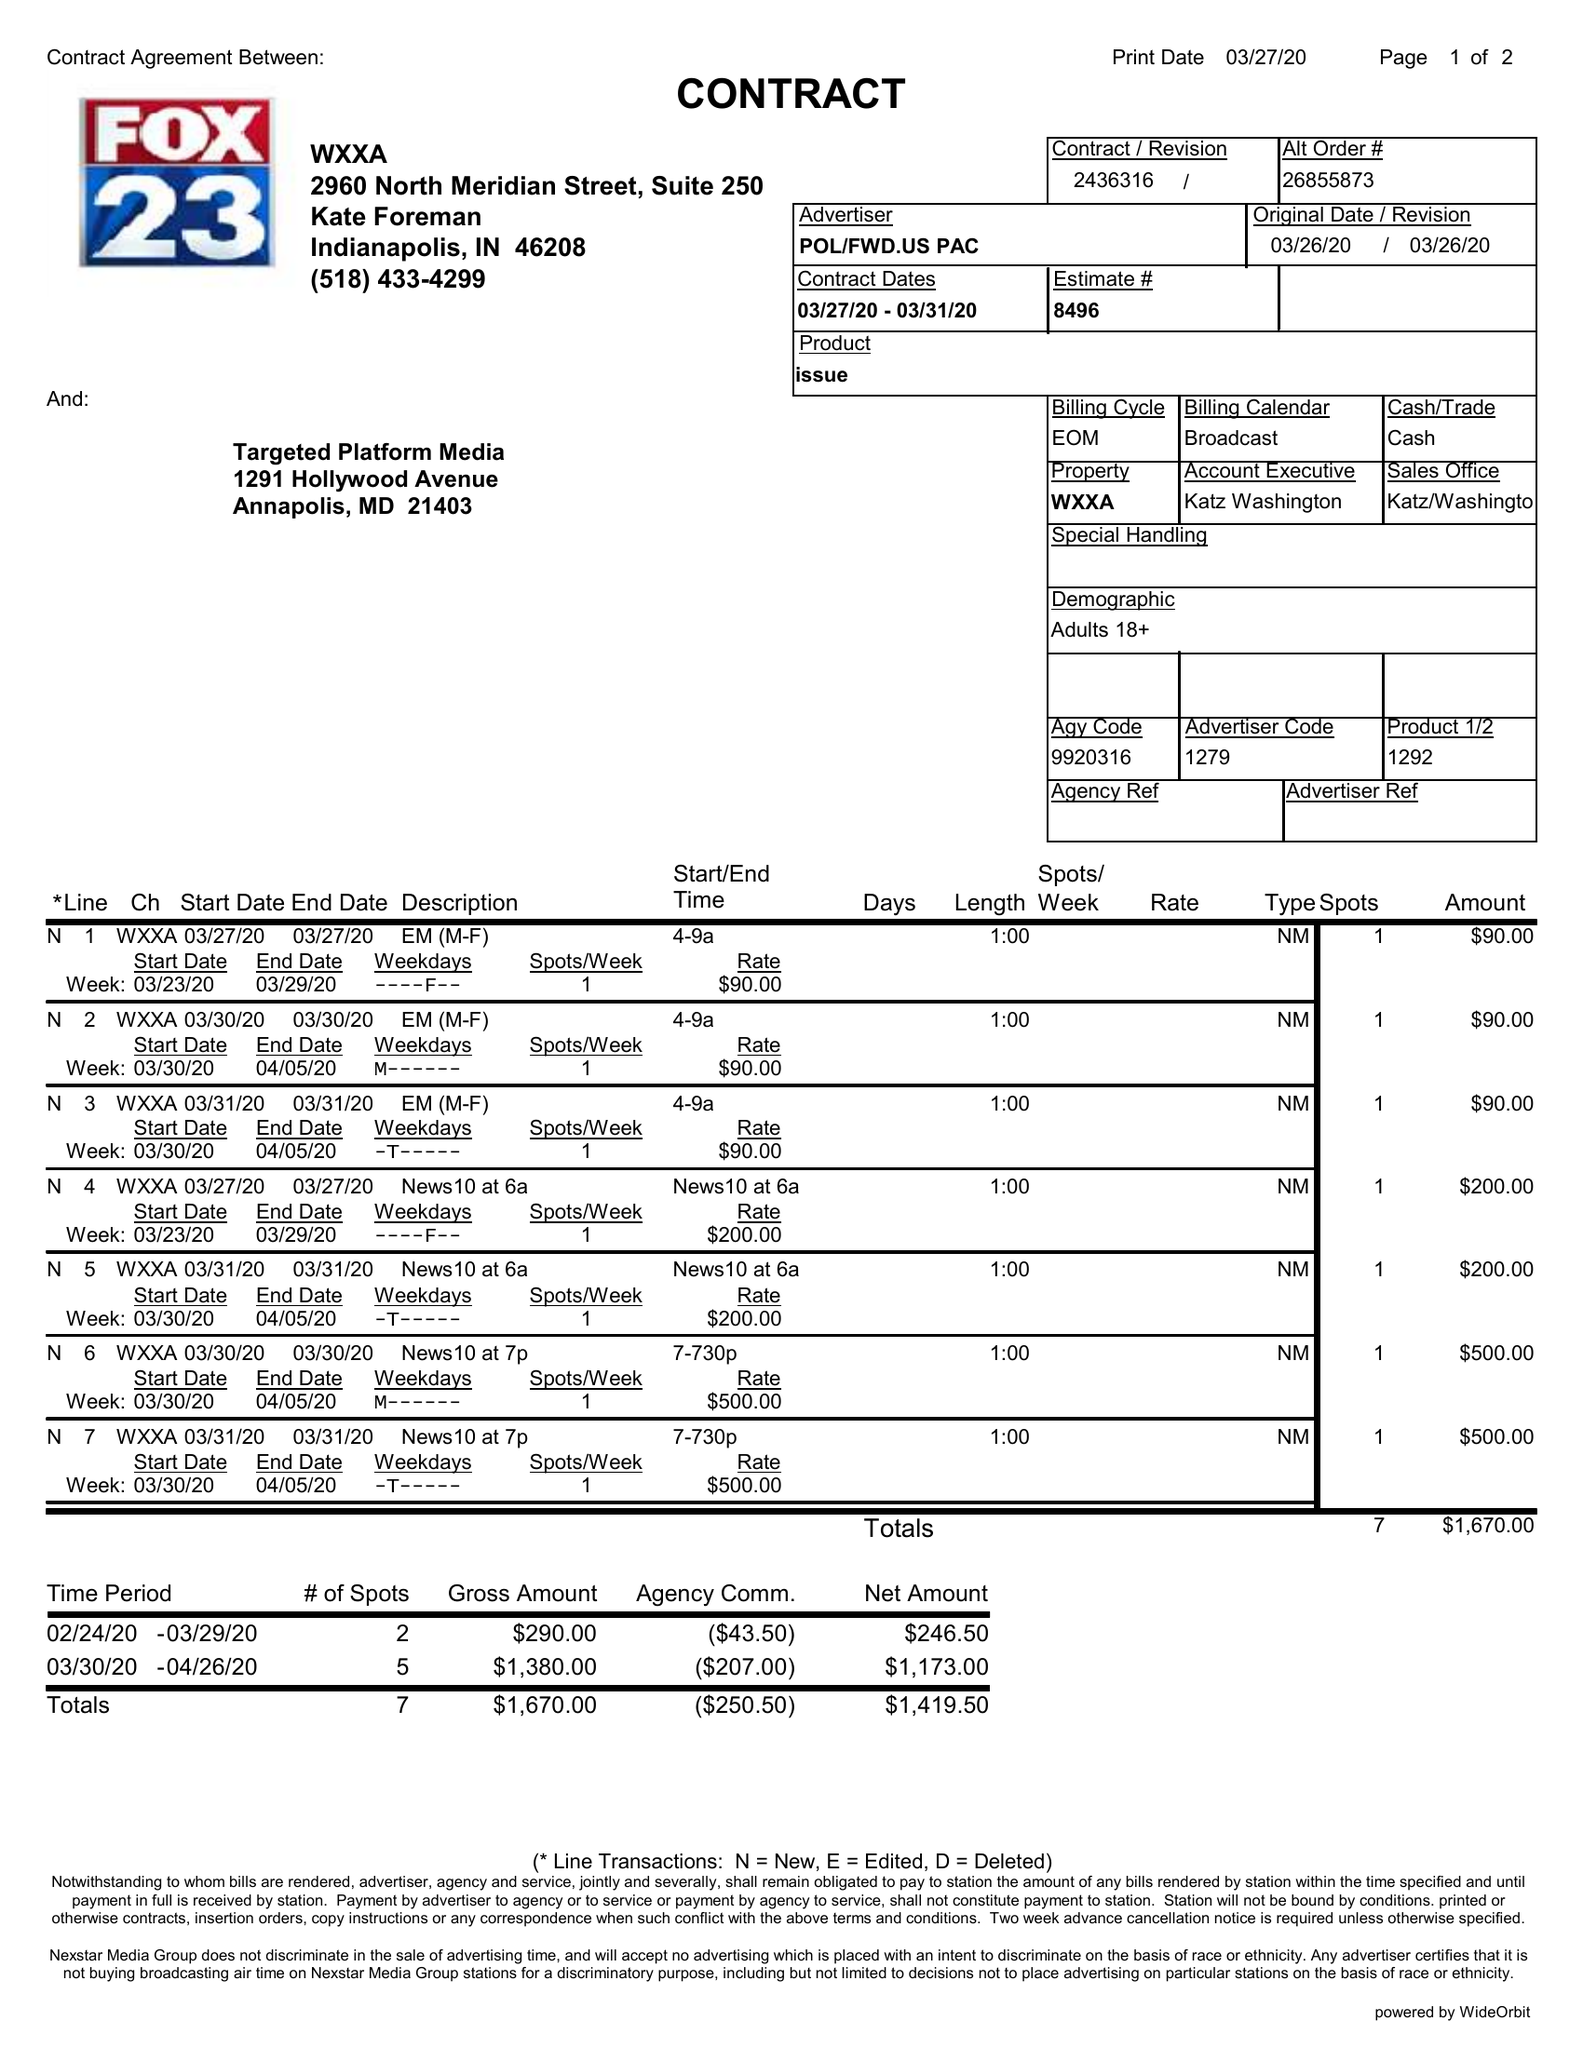What is the value for the contract_num?
Answer the question using a single word or phrase. 2436316 